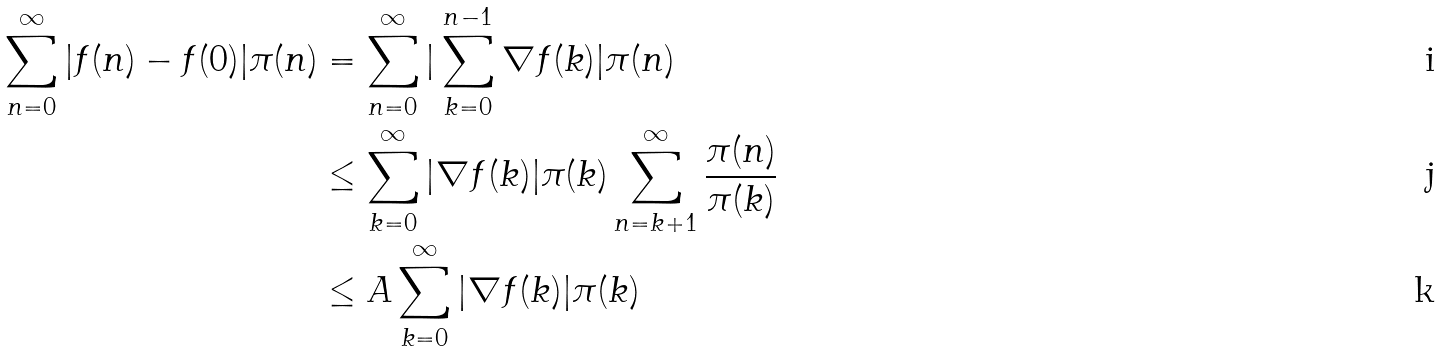<formula> <loc_0><loc_0><loc_500><loc_500>\sum _ { n = 0 } ^ { \infty } | f ( n ) - f ( 0 ) | \pi ( n ) & = \sum _ { n = 0 } ^ { \infty } | \sum _ { k = 0 } ^ { n - 1 } \nabla f ( k ) | \pi ( n ) \\ & \leq \sum _ { k = 0 } ^ { \infty } | \nabla f ( k ) | \pi ( k ) \sum _ { n = k + 1 } ^ { \infty } \frac { \pi ( n ) } { \pi ( k ) } \\ & \leq A \sum _ { k = 0 } ^ { \infty } | \nabla f ( k ) | \pi ( k )</formula> 